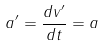<formula> <loc_0><loc_0><loc_500><loc_500>a ^ { \prime } = \frac { d v ^ { \prime } } { d t } = a</formula> 